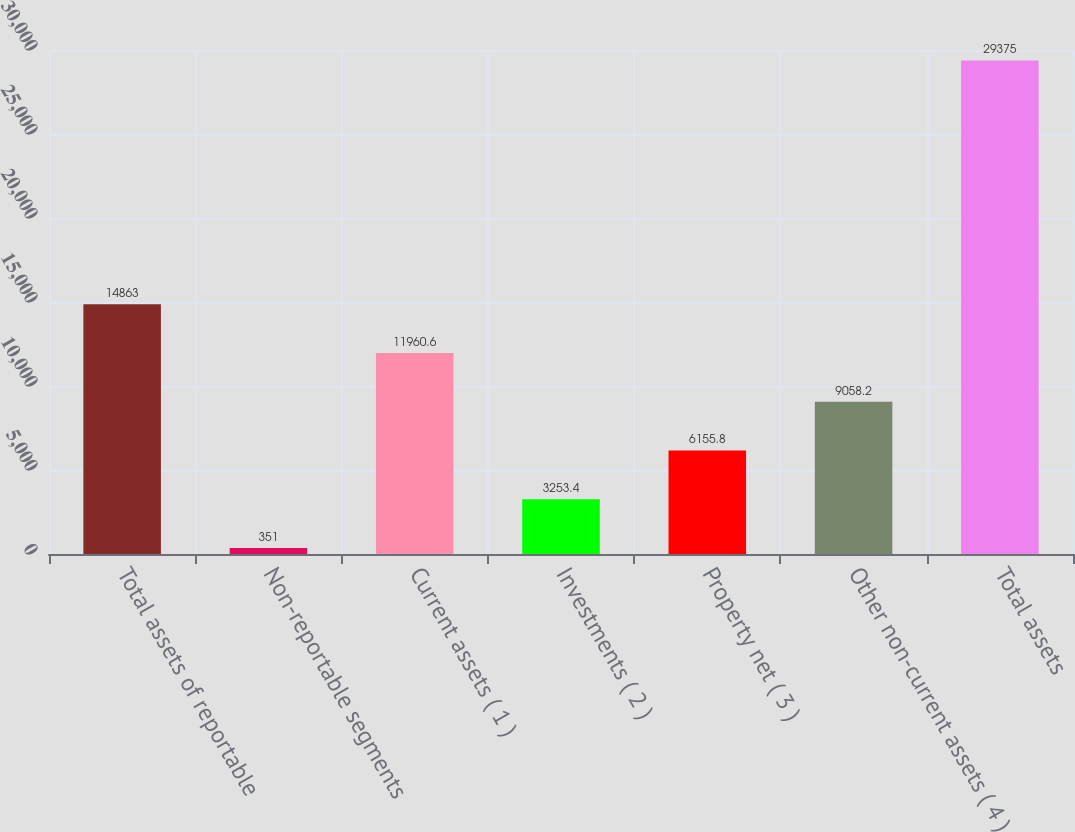<chart> <loc_0><loc_0><loc_500><loc_500><bar_chart><fcel>Total assets of reportable<fcel>Non-reportable segments<fcel>Current assets ( 1 )<fcel>Investments ( 2 )<fcel>Property net ( 3 )<fcel>Other non-current assets ( 4 )<fcel>Total assets<nl><fcel>14863<fcel>351<fcel>11960.6<fcel>3253.4<fcel>6155.8<fcel>9058.2<fcel>29375<nl></chart> 